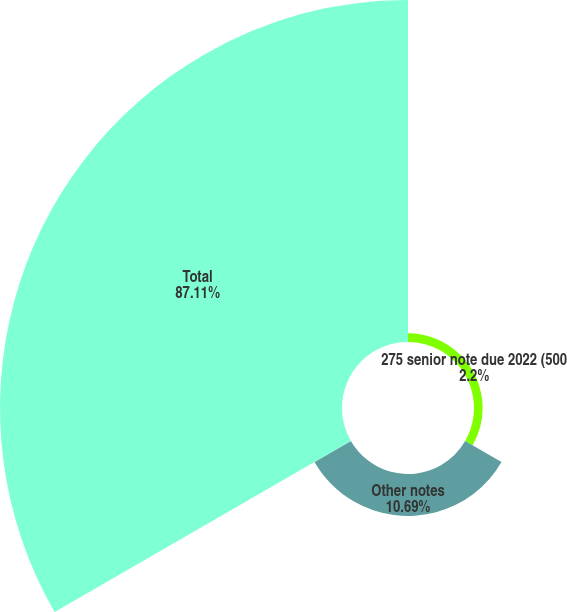Convert chart. <chart><loc_0><loc_0><loc_500><loc_500><pie_chart><fcel>275 senior note due 2022 (500<fcel>Other notes<fcel>Total<nl><fcel>2.2%<fcel>10.69%<fcel>87.11%<nl></chart> 